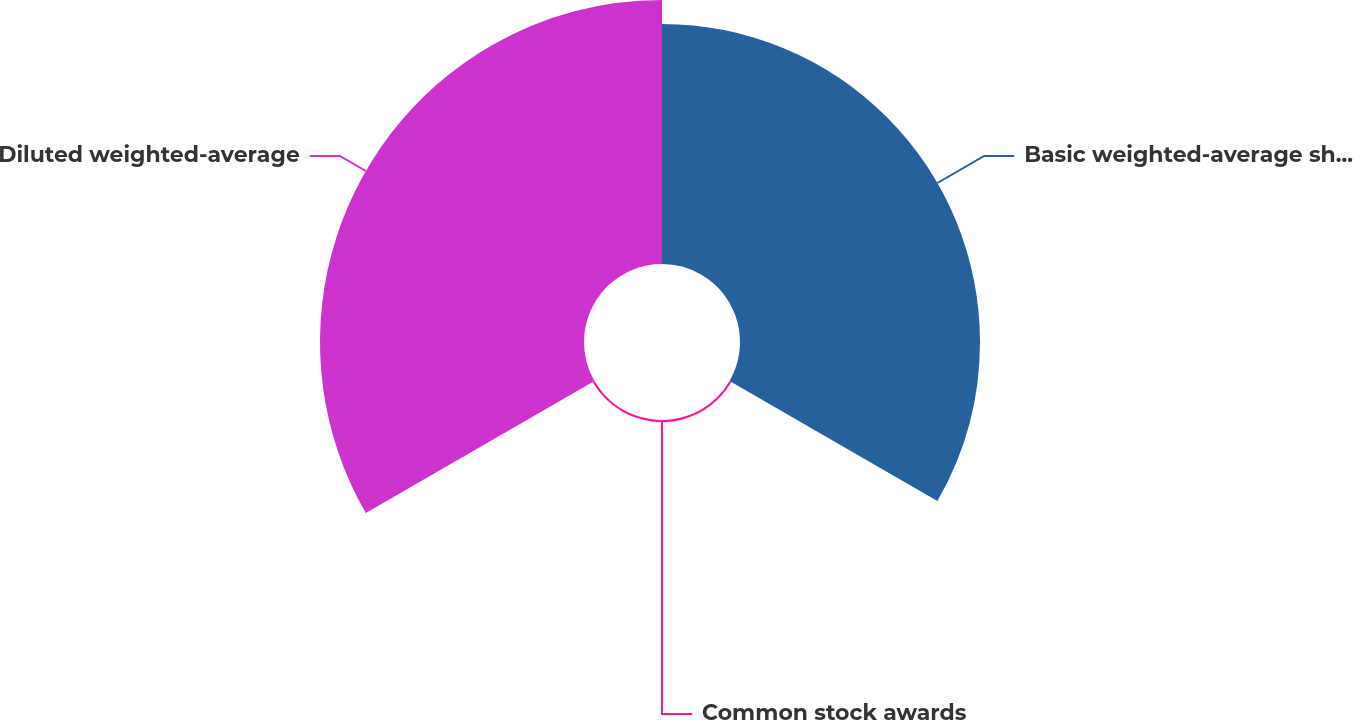Convert chart to OTSL. <chart><loc_0><loc_0><loc_500><loc_500><pie_chart><fcel>Basic weighted-average shares<fcel>Common stock awards<fcel>Diluted weighted-average<nl><fcel>47.42%<fcel>0.42%<fcel>52.16%<nl></chart> 